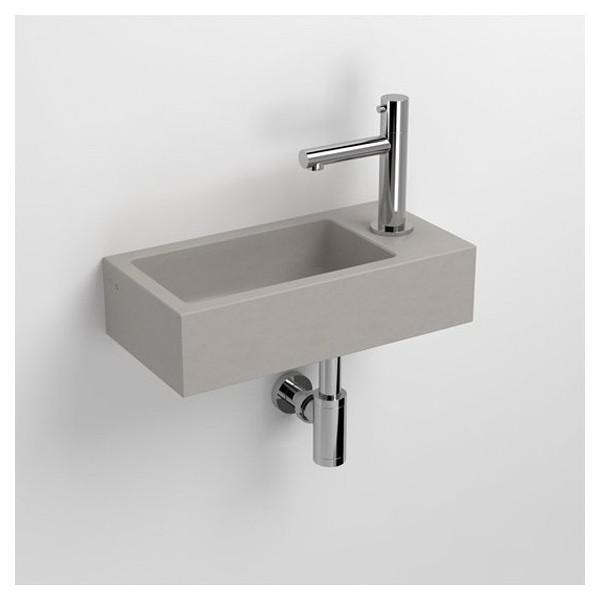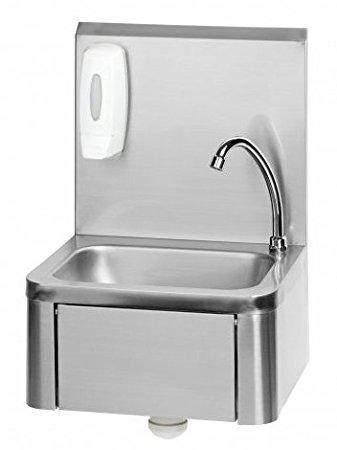The first image is the image on the left, the second image is the image on the right. For the images shown, is this caption "There is a square white sink with single faucet on top and cabinet underneath." true? Answer yes or no. No. The first image is the image on the left, the second image is the image on the right. For the images displayed, is the sentence "The sink in one image has a soap dispenser." factually correct? Answer yes or no. Yes. 